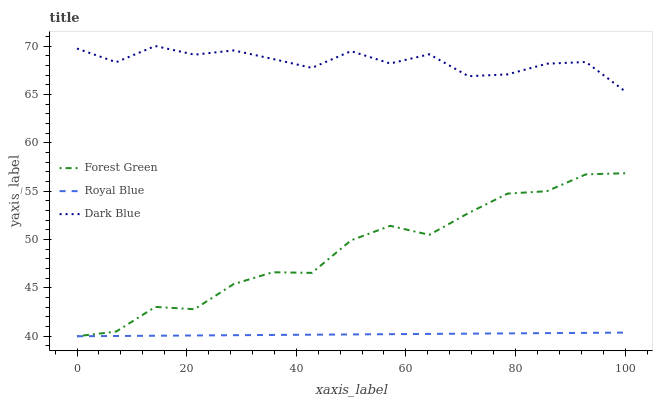Does Forest Green have the minimum area under the curve?
Answer yes or no. No. Does Forest Green have the maximum area under the curve?
Answer yes or no. No. Is Forest Green the smoothest?
Answer yes or no. No. Is Forest Green the roughest?
Answer yes or no. No. Does Dark Blue have the lowest value?
Answer yes or no. No. Does Forest Green have the highest value?
Answer yes or no. No. Is Royal Blue less than Dark Blue?
Answer yes or no. Yes. Is Dark Blue greater than Forest Green?
Answer yes or no. Yes. Does Royal Blue intersect Dark Blue?
Answer yes or no. No. 